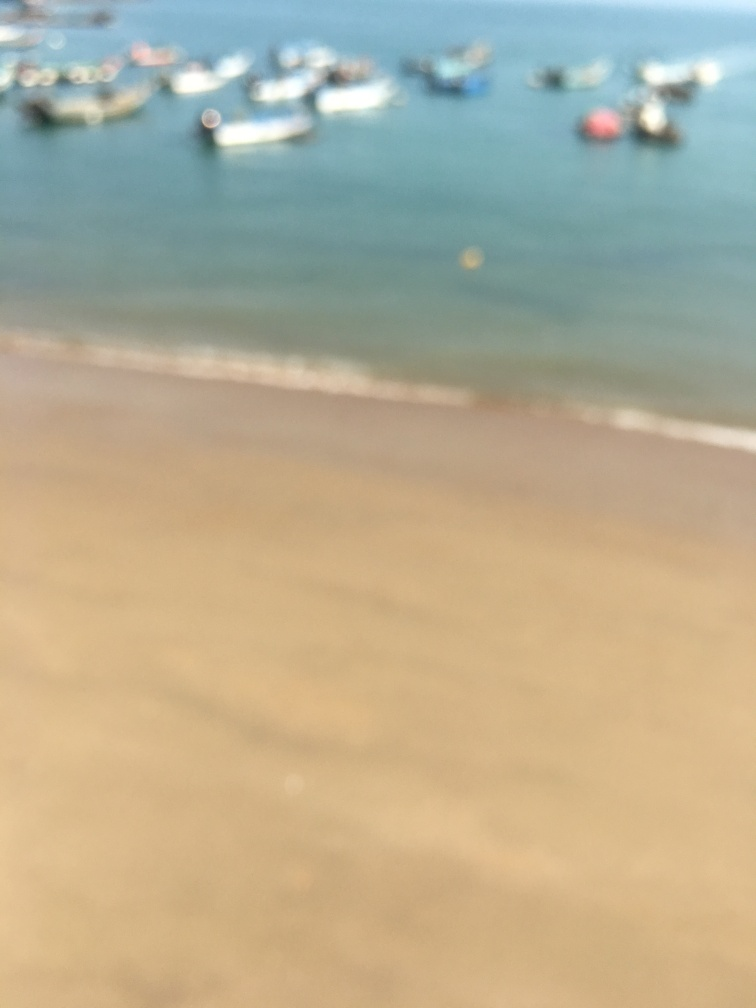Can you describe the setting or scene depicted in this image? While the image is blurry and specifics are difficult to discern, it appears to capture a beach scene with the edge of the water meeting the shore. There seem to be several boats or vessels floating in the water, suggesting a coastal area potentially used for fishing or recreation. 